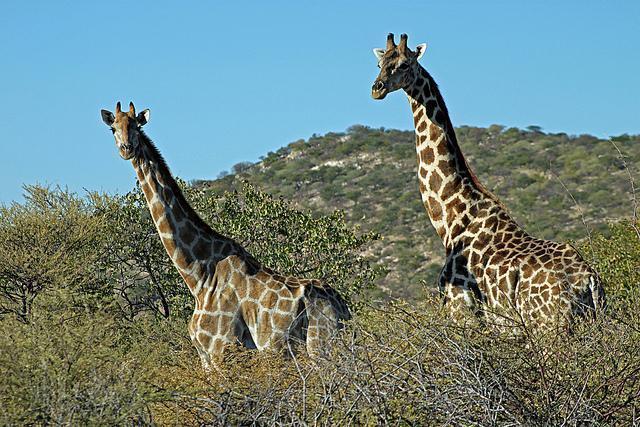How many giraffes are in this scene?
Give a very brief answer. 2. How many giraffes are looking at the camera?
Give a very brief answer. 1. How many giraffes can you see?
Give a very brief answer. 2. 